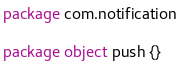Convert code to text. <code><loc_0><loc_0><loc_500><loc_500><_Scala_>package com.notification

package object push {}
</code> 